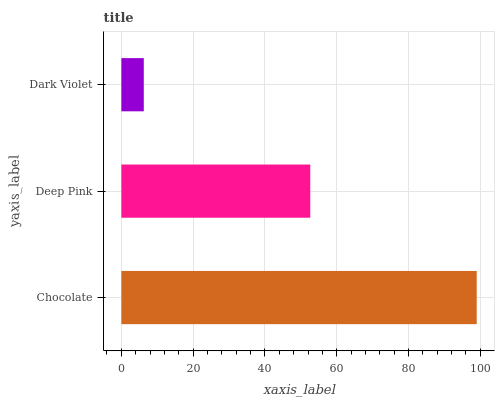Is Dark Violet the minimum?
Answer yes or no. Yes. Is Chocolate the maximum?
Answer yes or no. Yes. Is Deep Pink the minimum?
Answer yes or no. No. Is Deep Pink the maximum?
Answer yes or no. No. Is Chocolate greater than Deep Pink?
Answer yes or no. Yes. Is Deep Pink less than Chocolate?
Answer yes or no. Yes. Is Deep Pink greater than Chocolate?
Answer yes or no. No. Is Chocolate less than Deep Pink?
Answer yes or no. No. Is Deep Pink the high median?
Answer yes or no. Yes. Is Deep Pink the low median?
Answer yes or no. Yes. Is Chocolate the high median?
Answer yes or no. No. Is Chocolate the low median?
Answer yes or no. No. 